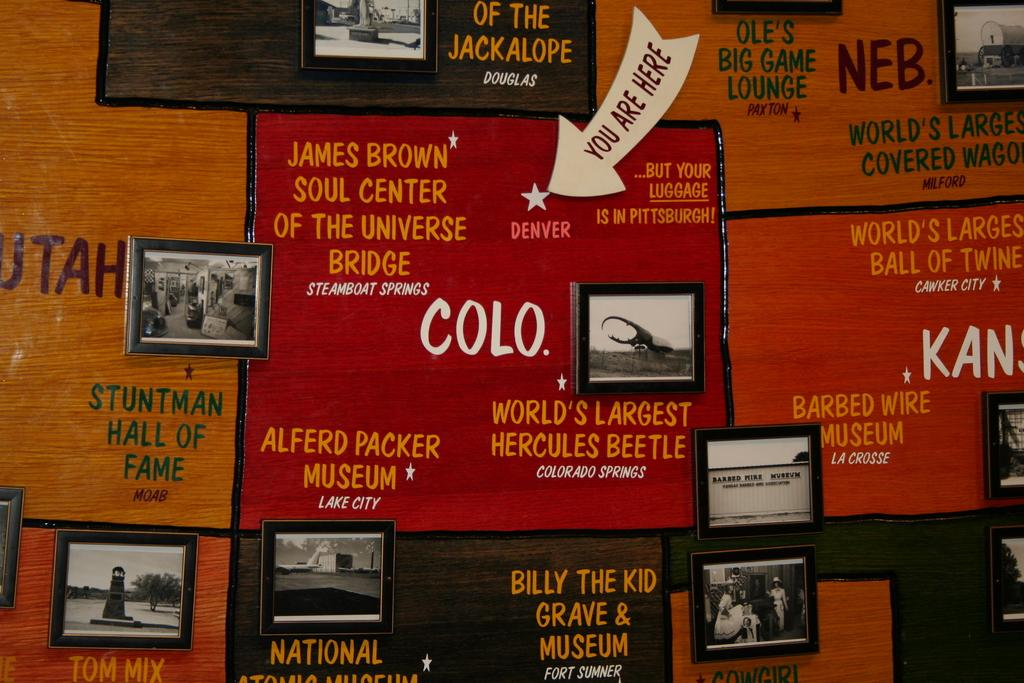<image>
Describe the image concisely. A close up of a map is shown with Colorado in the center of the image and it highlights the "Alfred Packer Museum" and "World's Largest Hercules Beetle." 